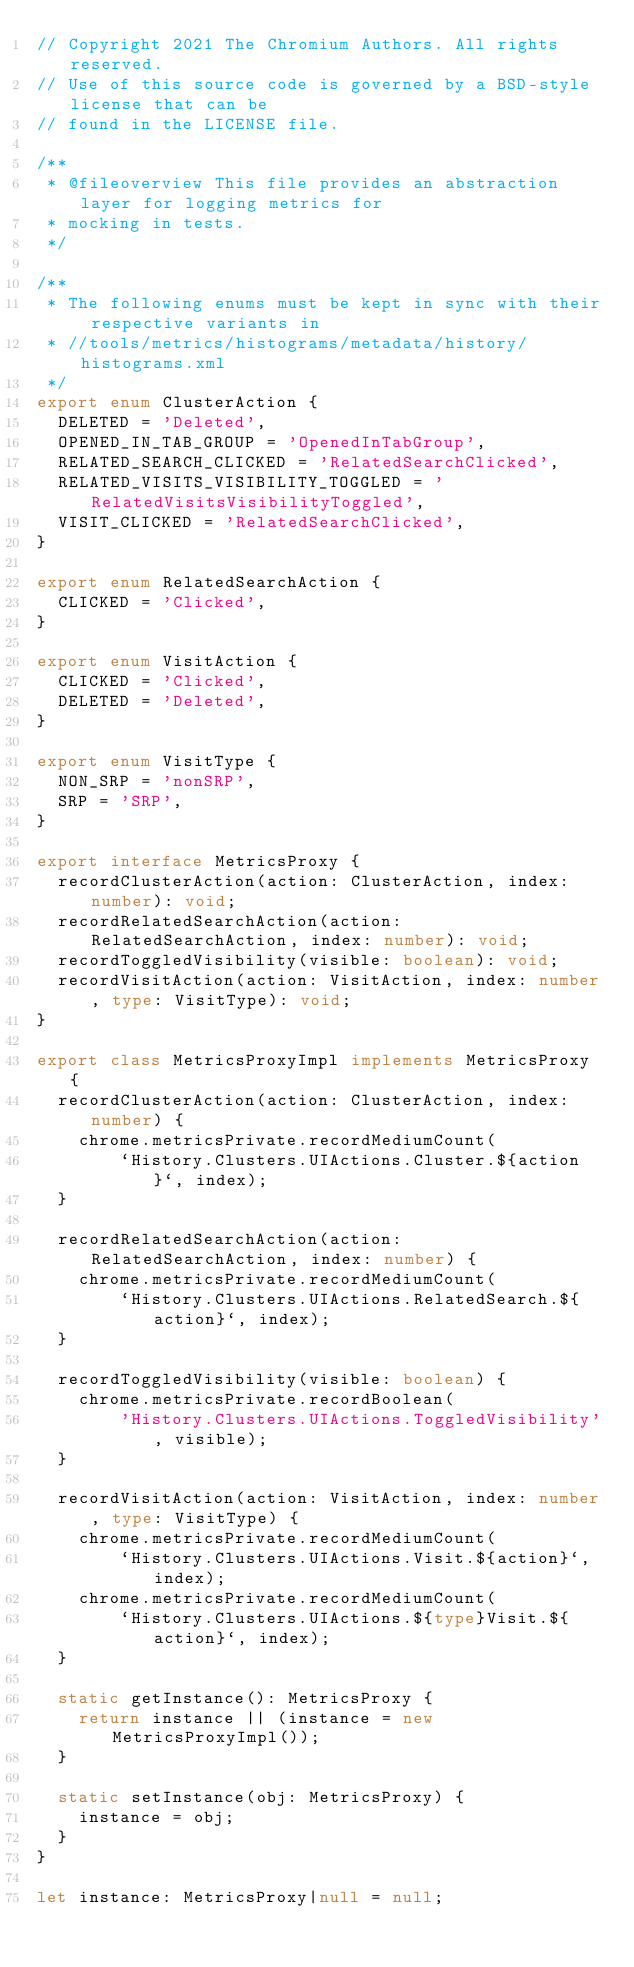Convert code to text. <code><loc_0><loc_0><loc_500><loc_500><_TypeScript_>// Copyright 2021 The Chromium Authors. All rights reserved.
// Use of this source code is governed by a BSD-style license that can be
// found in the LICENSE file.

/**
 * @fileoverview This file provides an abstraction layer for logging metrics for
 * mocking in tests.
 */

/**
 * The following enums must be kept in sync with their respective variants in
 * //tools/metrics/histograms/metadata/history/histograms.xml
 */
export enum ClusterAction {
  DELETED = 'Deleted',
  OPENED_IN_TAB_GROUP = 'OpenedInTabGroup',
  RELATED_SEARCH_CLICKED = 'RelatedSearchClicked',
  RELATED_VISITS_VISIBILITY_TOGGLED = 'RelatedVisitsVisibilityToggled',
  VISIT_CLICKED = 'RelatedSearchClicked',
}

export enum RelatedSearchAction {
  CLICKED = 'Clicked',
}

export enum VisitAction {
  CLICKED = 'Clicked',
  DELETED = 'Deleted',
}

export enum VisitType {
  NON_SRP = 'nonSRP',
  SRP = 'SRP',
}

export interface MetricsProxy {
  recordClusterAction(action: ClusterAction, index: number): void;
  recordRelatedSearchAction(action: RelatedSearchAction, index: number): void;
  recordToggledVisibility(visible: boolean): void;
  recordVisitAction(action: VisitAction, index: number, type: VisitType): void;
}

export class MetricsProxyImpl implements MetricsProxy {
  recordClusterAction(action: ClusterAction, index: number) {
    chrome.metricsPrivate.recordMediumCount(
        `History.Clusters.UIActions.Cluster.${action}`, index);
  }

  recordRelatedSearchAction(action: RelatedSearchAction, index: number) {
    chrome.metricsPrivate.recordMediumCount(
        `History.Clusters.UIActions.RelatedSearch.${action}`, index);
  }

  recordToggledVisibility(visible: boolean) {
    chrome.metricsPrivate.recordBoolean(
        'History.Clusters.UIActions.ToggledVisibility', visible);
  }

  recordVisitAction(action: VisitAction, index: number, type: VisitType) {
    chrome.metricsPrivate.recordMediumCount(
        `History.Clusters.UIActions.Visit.${action}`, index);
    chrome.metricsPrivate.recordMediumCount(
        `History.Clusters.UIActions.${type}Visit.${action}`, index);
  }

  static getInstance(): MetricsProxy {
    return instance || (instance = new MetricsProxyImpl());
  }

  static setInstance(obj: MetricsProxy) {
    instance = obj;
  }
}

let instance: MetricsProxy|null = null;
</code> 